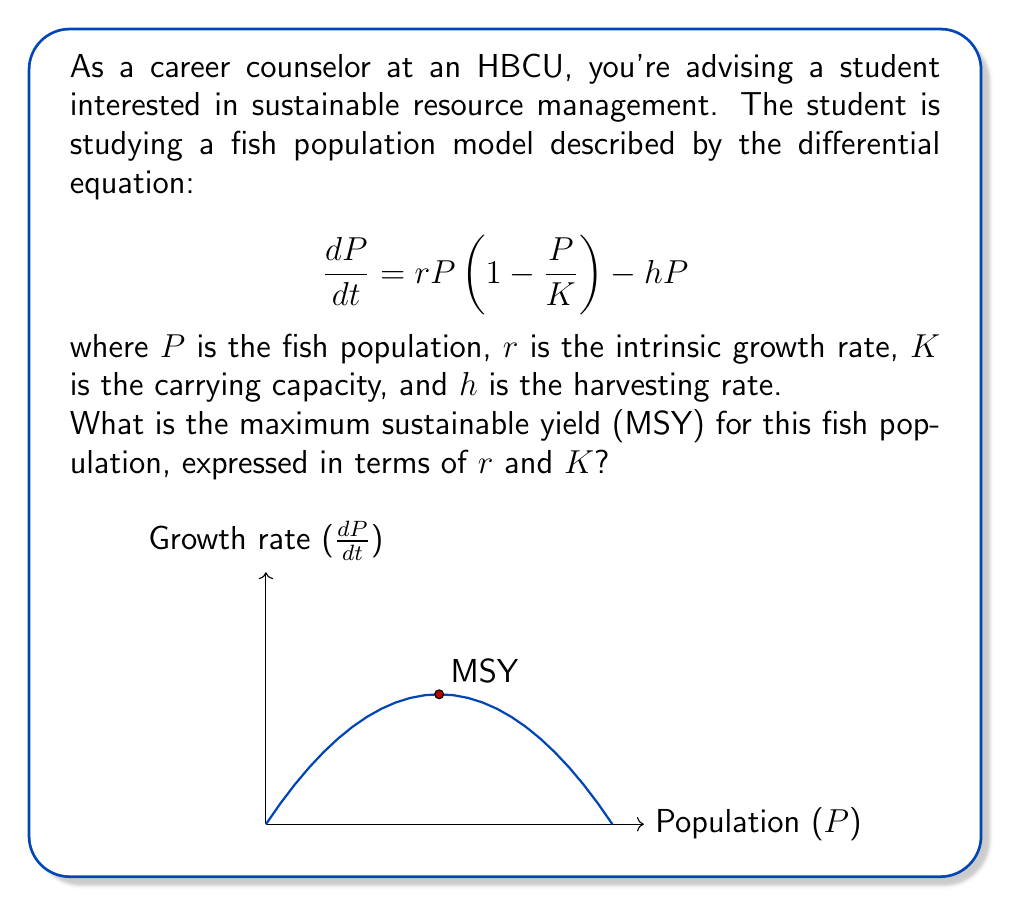Provide a solution to this math problem. Let's approach this step-by-step:

1) The maximum sustainable yield occurs when the growth rate is at its maximum. To find this, we need to find the maximum of the function:

   $$\frac{dP}{dt} = rP(1-\frac{P}{K}) - hP$$

2) At equilibrium, $\frac{dP}{dt} = 0$, so:

   $$rP(1-\frac{P}{K}) - hP = 0$$

3) Solving for $h$:

   $$h = r(1-\frac{P}{K})$$

4) The harvesting rate $h$ is maximized when $\frac{dh}{dP} = 0$:

   $$\frac{dh}{dP} = -\frac{r}{K} = 0$$

5) This is always negative, so the maximum occurs at the midpoint between 0 and $K$, i.e., when $P = \frac{K}{2}$.

6) Substituting this back into the equation for $h$:

   $$h_{max} = r(1-\frac{K/2}{K}) = r(1-\frac{1}{2}) = \frac{r}{2}$$

7) The maximum sustainable yield is this harvesting rate multiplied by the population size:

   $$MSY = h_{max} \cdot P = \frac{r}{2} \cdot \frac{K}{2} = \frac{rK}{4}$$

Thus, the maximum sustainable yield is $\frac{rK}{4}$.
Answer: $\frac{rK}{4}$ 